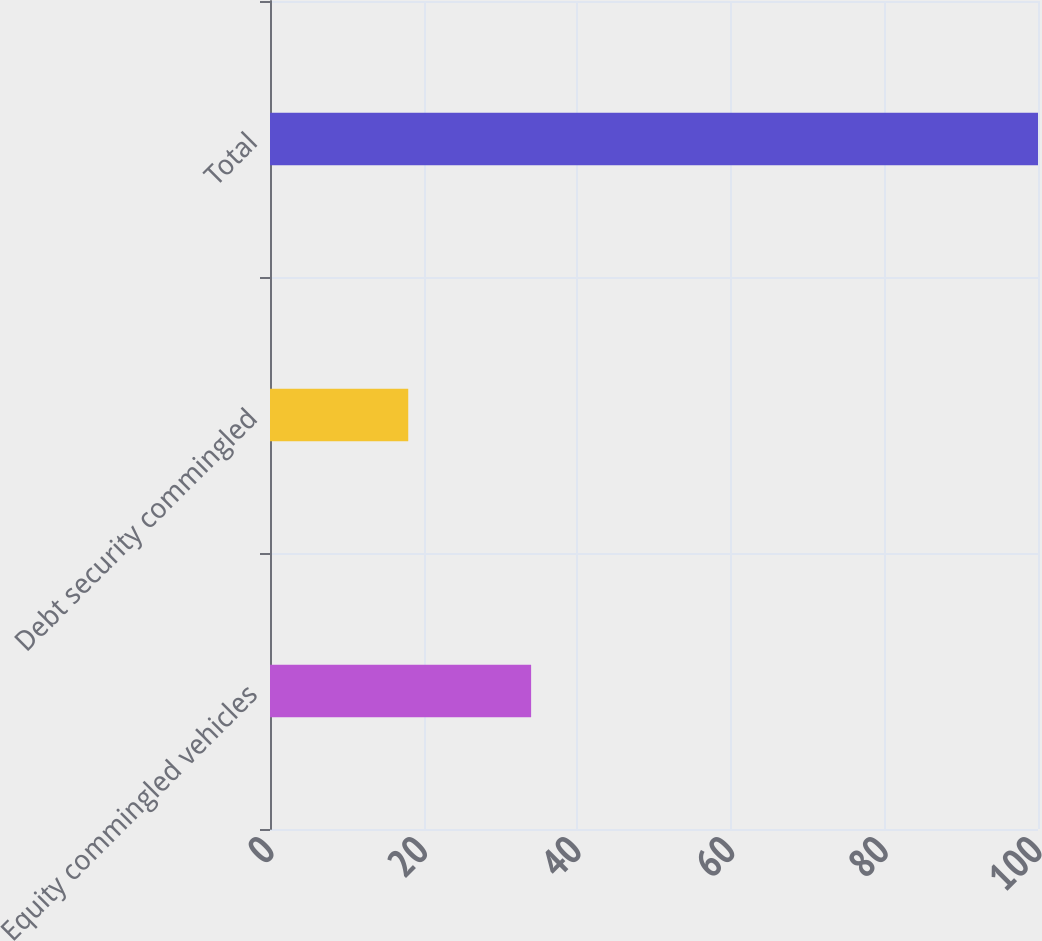<chart> <loc_0><loc_0><loc_500><loc_500><bar_chart><fcel>Equity commingled vehicles<fcel>Debt security commingled<fcel>Total<nl><fcel>34<fcel>18<fcel>100<nl></chart> 